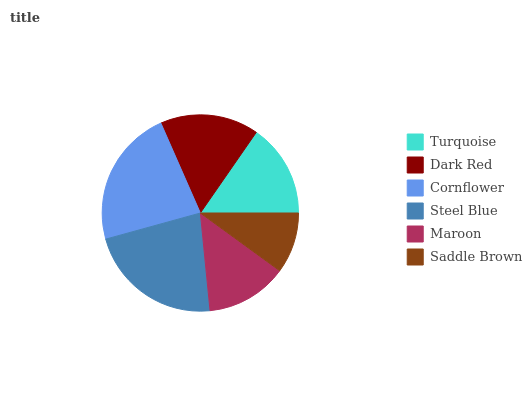Is Saddle Brown the minimum?
Answer yes or no. Yes. Is Cornflower the maximum?
Answer yes or no. Yes. Is Dark Red the minimum?
Answer yes or no. No. Is Dark Red the maximum?
Answer yes or no. No. Is Dark Red greater than Turquoise?
Answer yes or no. Yes. Is Turquoise less than Dark Red?
Answer yes or no. Yes. Is Turquoise greater than Dark Red?
Answer yes or no. No. Is Dark Red less than Turquoise?
Answer yes or no. No. Is Dark Red the high median?
Answer yes or no. Yes. Is Turquoise the low median?
Answer yes or no. Yes. Is Cornflower the high median?
Answer yes or no. No. Is Cornflower the low median?
Answer yes or no. No. 